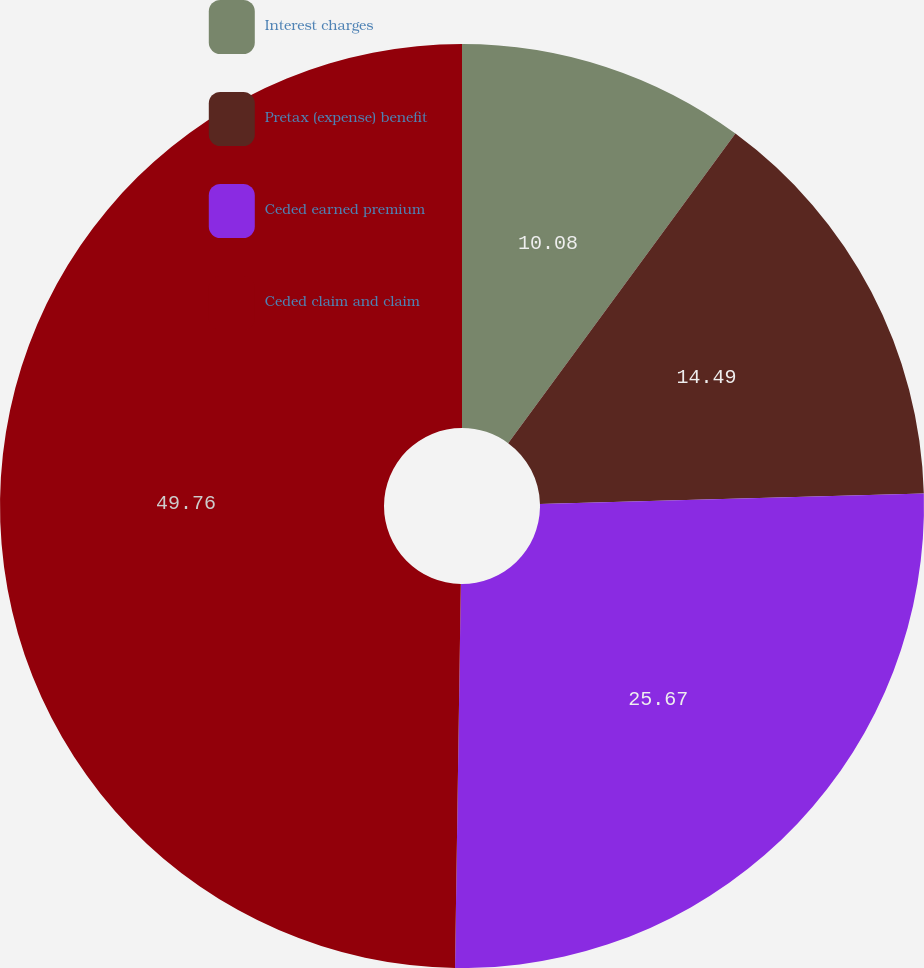Convert chart. <chart><loc_0><loc_0><loc_500><loc_500><pie_chart><fcel>Interest charges<fcel>Pretax (expense) benefit<fcel>Ceded earned premium<fcel>Ceded claim and claim<nl><fcel>10.08%<fcel>14.49%<fcel>25.67%<fcel>49.76%<nl></chart> 